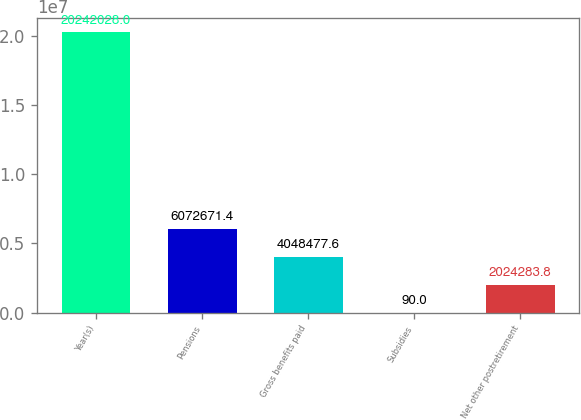Convert chart. <chart><loc_0><loc_0><loc_500><loc_500><bar_chart><fcel>Year(s)<fcel>Pensions<fcel>Gross benefits paid<fcel>Subsidies<fcel>Net other postretirement<nl><fcel>2.0242e+07<fcel>6.07267e+06<fcel>4.04848e+06<fcel>90<fcel>2.02428e+06<nl></chart> 